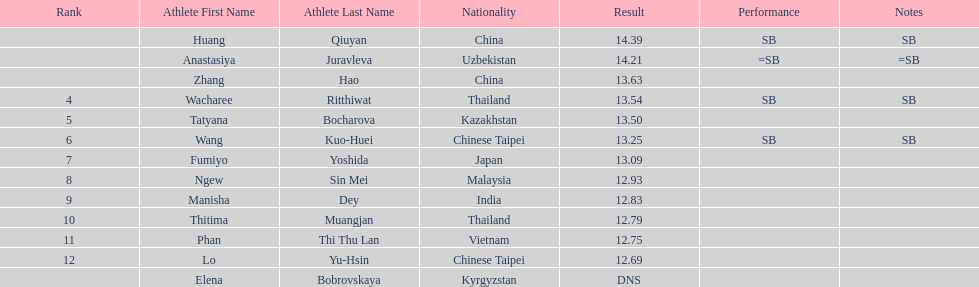What was the average result of the top three jumpers? 14.08. 